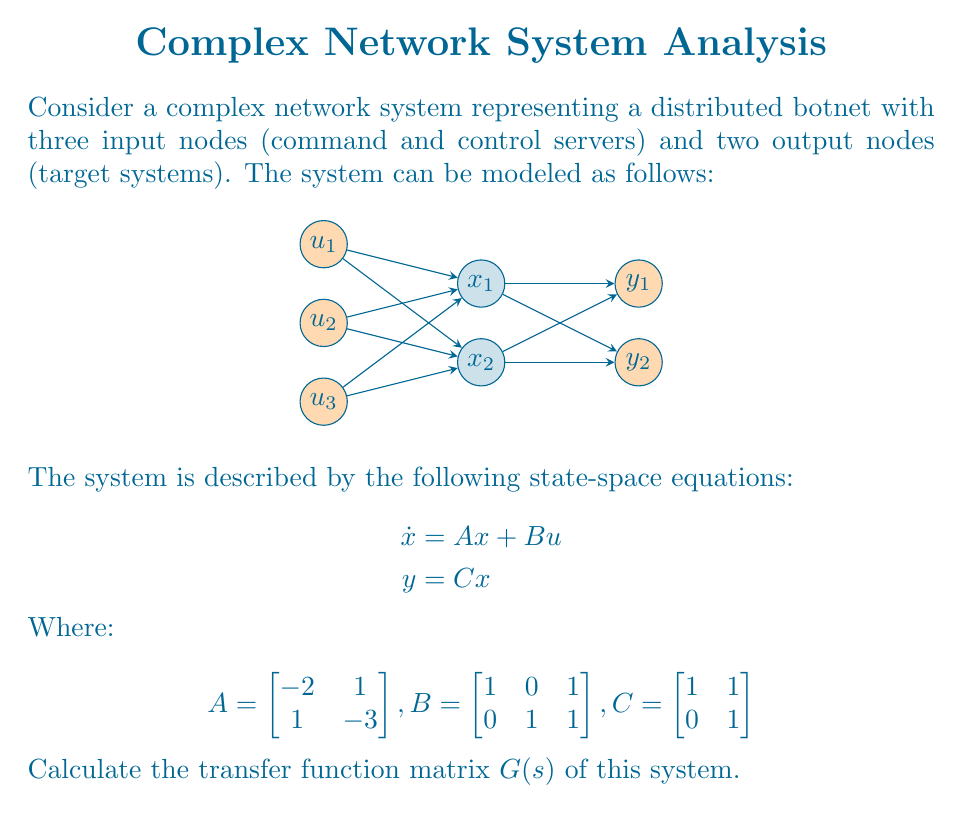Solve this math problem. To find the transfer function matrix $G(s)$ of the given system, we need to follow these steps:

1) The transfer function matrix for a state-space system is given by:

   $$G(s) = C(sI - A)^{-1}B$$

   where $I$ is the identity matrix of the same size as $A$.

2) First, let's calculate $(sI - A)$:

   $$sI - A = \begin{bmatrix} s & 0 \\ 0 & s \end{bmatrix} - \begin{bmatrix} -2 & 1 \\ 1 & -3 \end{bmatrix} = \begin{bmatrix} s+2 & -1 \\ -1 & s+3 \end{bmatrix}$$

3) Now, we need to find $(sI - A)^{-1}$. For a 2x2 matrix, the inverse is:

   $$(sI - A)^{-1} = \frac{1}{det(sI-A)} \begin{bmatrix} s+3 & 1 \\ 1 & s+2 \end{bmatrix}$$

   where $det(sI-A) = (s+2)(s+3) - (-1)(-1) = s^2 + 5s + 5$

4) So, $(sI - A)^{-1} = \frac{1}{s^2 + 5s + 5} \begin{bmatrix} s+3 & 1 \\ 1 & s+2 \end{bmatrix}$

5) Now, let's multiply $C(sI - A)^{-1}$:

   $$C(sI - A)^{-1} = \frac{1}{s^2 + 5s + 5} \begin{bmatrix} 1 & 1 \\ 0 & 1 \end{bmatrix} \begin{bmatrix} s+3 & 1 \\ 1 & s+2 \end{bmatrix}$$

   $$= \frac{1}{s^2 + 5s + 5} \begin{bmatrix} s+4 & s+3 \\ 1 & s+2 \end{bmatrix}$$

6) Finally, we multiply this result by $B$:

   $$G(s) = C(sI - A)^{-1}B = \frac{1}{s^2 + 5s + 5} \begin{bmatrix} s+4 & s+3 \\ 1 & s+2 \end{bmatrix} \begin{bmatrix} 1 & 0 & 1 \\ 0 & 1 & 1 \end{bmatrix}$$

   $$= \frac{1}{s^2 + 5s + 5} \begin{bmatrix} s+4 & s+3 & 2s+7 \\ 1 & s+2 & s+3 \end{bmatrix}$$

This is the transfer function matrix $G(s)$ of the system.
Answer: $$G(s) = \frac{1}{s^2 + 5s + 5} \begin{bmatrix} s+4 & s+3 & 2s+7 \\ 1 & s+2 & s+3 \end{bmatrix}$$ 